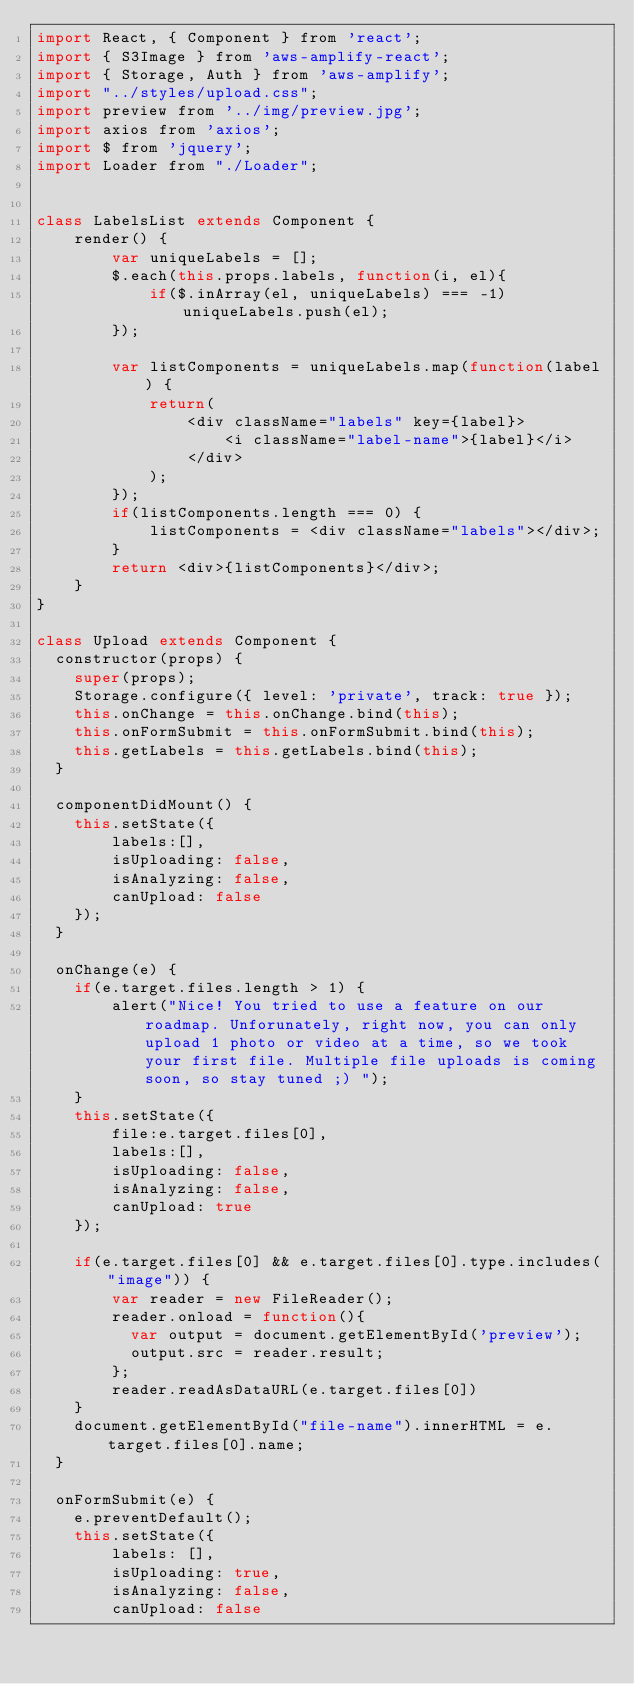Convert code to text. <code><loc_0><loc_0><loc_500><loc_500><_JavaScript_>import React, { Component } from 'react';
import { S3Image } from 'aws-amplify-react';
import { Storage, Auth } from 'aws-amplify';
import "../styles/upload.css";
import preview from '../img/preview.jpg';
import axios from 'axios';
import $ from 'jquery';
import Loader from "./Loader";


class LabelsList extends Component {
    render() {
		var uniqueLabels = [];
		$.each(this.props.labels, function(i, el){
		    if($.inArray(el, uniqueLabels) === -1) uniqueLabels.push(el);
		});

		var listComponents = uniqueLabels.map(function(label) {
            return(
            	<div className="labels" key={label}>
            		<i className="label-name">{label}</i>
        		</div>
        	);
        });
        if(listComponents.length === 0) {
        	listComponents = <div className="labels"></div>;
        }
        return <div>{listComponents}</div>;
    }
}

class Upload extends Component {
  constructor(props) {
    super(props);
    Storage.configure({ level: 'private', track: true });
    this.onChange = this.onChange.bind(this);
    this.onFormSubmit = this.onFormSubmit.bind(this);
    this.getLabels = this.getLabels.bind(this);
  }

  componentDidMount() {
  	this.setState({
  		labels:[],
  		isUploading: false,
  		isAnalyzing: false,
  		canUpload: false
  	});
  }

  onChange(e) {
  	if(e.target.files.length > 1) {
  		alert("Nice! You tried to use a feature on our roadmap. Unforunately, right now, you can only upload 1 photo or video at a time, so we took your first file. Multiple file uploads is coming soon, so stay tuned ;) ");
  	}
  	this.setState({
  		file:e.target.files[0],
  		labels:[],
  		isUploading: false,
  		isAnalyzing: false,
  		canUpload: true
  	});

  	if(e.target.files[0] && e.target.files[0].type.includes("image")) {
  		var reader = new FileReader();
	    reader.onload = function(){
	      var output = document.getElementById('preview');
	      output.src = reader.result;
	    };
	    reader.readAsDataURL(e.target.files[0])
  	}
  	document.getElementById("file-name").innerHTML = e.target.files[0].name;
  }

  onFormSubmit(e) {
  	e.preventDefault();
	this.setState({
		labels: [],
		isUploading: true,
		isAnalyzing: false,
		canUpload: false</code> 